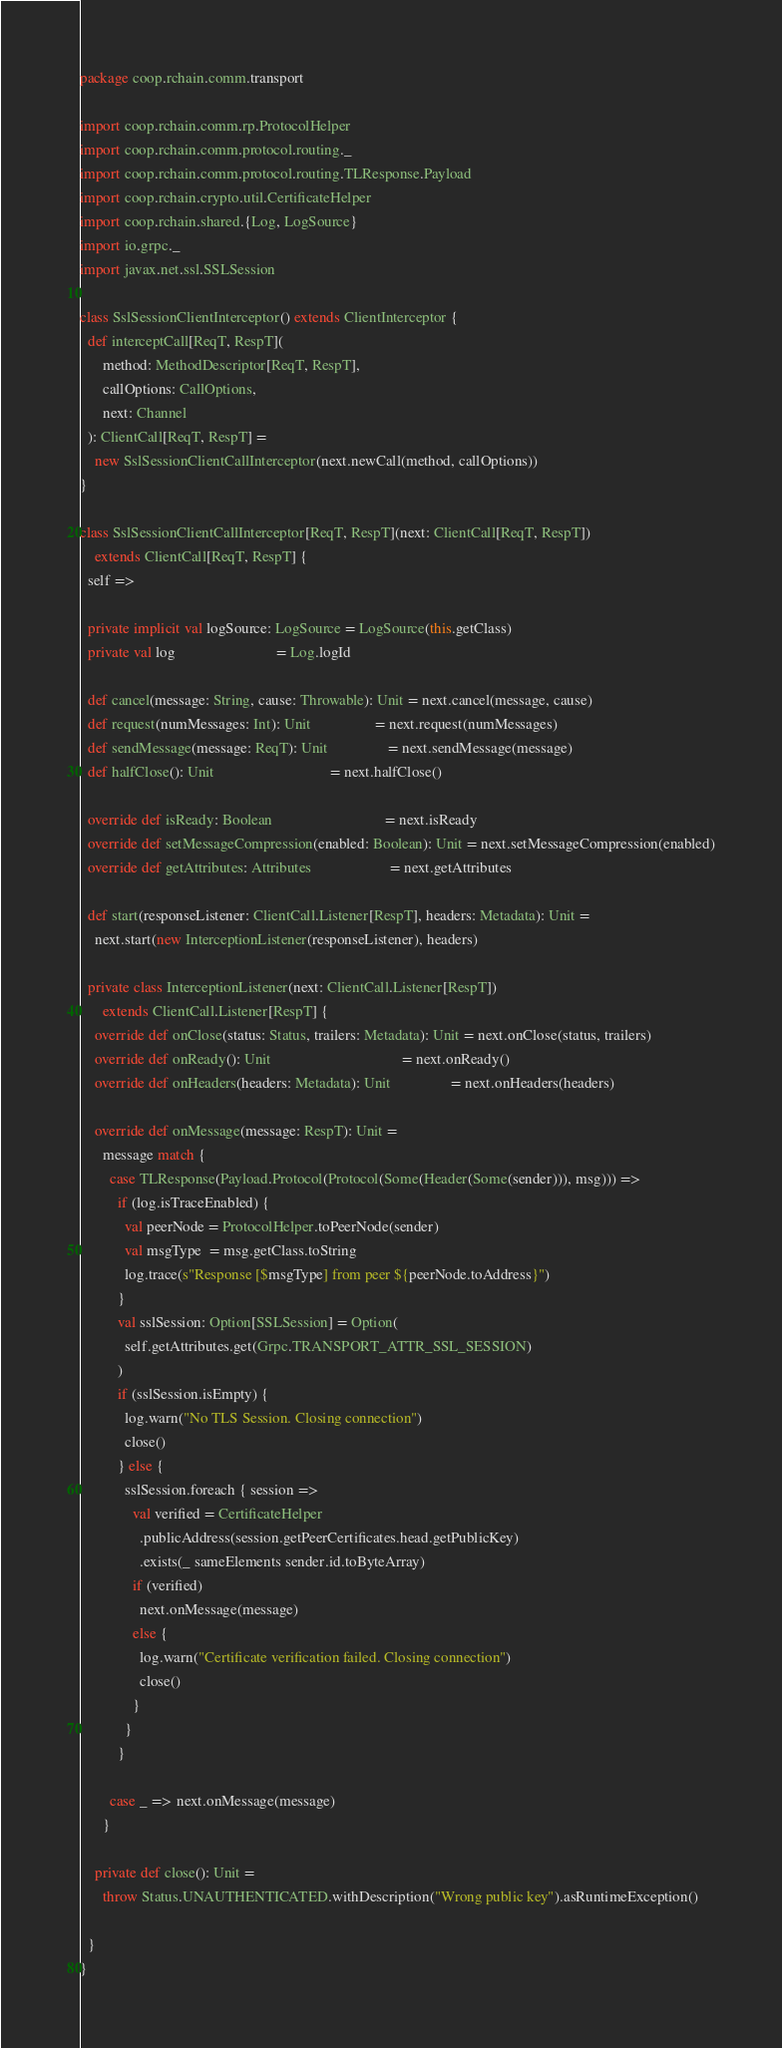<code> <loc_0><loc_0><loc_500><loc_500><_Scala_>package coop.rchain.comm.transport

import coop.rchain.comm.rp.ProtocolHelper
import coop.rchain.comm.protocol.routing._
import coop.rchain.comm.protocol.routing.TLResponse.Payload
import coop.rchain.crypto.util.CertificateHelper
import coop.rchain.shared.{Log, LogSource}
import io.grpc._
import javax.net.ssl.SSLSession

class SslSessionClientInterceptor() extends ClientInterceptor {
  def interceptCall[ReqT, RespT](
      method: MethodDescriptor[ReqT, RespT],
      callOptions: CallOptions,
      next: Channel
  ): ClientCall[ReqT, RespT] =
    new SslSessionClientCallInterceptor(next.newCall(method, callOptions))
}

class SslSessionClientCallInterceptor[ReqT, RespT](next: ClientCall[ReqT, RespT])
    extends ClientCall[ReqT, RespT] {
  self =>

  private implicit val logSource: LogSource = LogSource(this.getClass)
  private val log                           = Log.logId

  def cancel(message: String, cause: Throwable): Unit = next.cancel(message, cause)
  def request(numMessages: Int): Unit                 = next.request(numMessages)
  def sendMessage(message: ReqT): Unit                = next.sendMessage(message)
  def halfClose(): Unit                               = next.halfClose()

  override def isReady: Boolean                              = next.isReady
  override def setMessageCompression(enabled: Boolean): Unit = next.setMessageCompression(enabled)
  override def getAttributes: Attributes                     = next.getAttributes

  def start(responseListener: ClientCall.Listener[RespT], headers: Metadata): Unit =
    next.start(new InterceptionListener(responseListener), headers)

  private class InterceptionListener(next: ClientCall.Listener[RespT])
      extends ClientCall.Listener[RespT] {
    override def onClose(status: Status, trailers: Metadata): Unit = next.onClose(status, trailers)
    override def onReady(): Unit                                   = next.onReady()
    override def onHeaders(headers: Metadata): Unit                = next.onHeaders(headers)

    override def onMessage(message: RespT): Unit =
      message match {
        case TLResponse(Payload.Protocol(Protocol(Some(Header(Some(sender))), msg))) =>
          if (log.isTraceEnabled) {
            val peerNode = ProtocolHelper.toPeerNode(sender)
            val msgType  = msg.getClass.toString
            log.trace(s"Response [$msgType] from peer ${peerNode.toAddress}")
          }
          val sslSession: Option[SSLSession] = Option(
            self.getAttributes.get(Grpc.TRANSPORT_ATTR_SSL_SESSION)
          )
          if (sslSession.isEmpty) {
            log.warn("No TLS Session. Closing connection")
            close()
          } else {
            sslSession.foreach { session =>
              val verified = CertificateHelper
                .publicAddress(session.getPeerCertificates.head.getPublicKey)
                .exists(_ sameElements sender.id.toByteArray)
              if (verified)
                next.onMessage(message)
              else {
                log.warn("Certificate verification failed. Closing connection")
                close()
              }
            }
          }

        case _ => next.onMessage(message)
      }

    private def close(): Unit =
      throw Status.UNAUTHENTICATED.withDescription("Wrong public key").asRuntimeException()

  }
}
</code> 